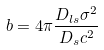<formula> <loc_0><loc_0><loc_500><loc_500>b = 4 \pi \frac { D _ { l s } \sigma ^ { 2 } } { D _ { s } c ^ { 2 } }</formula> 